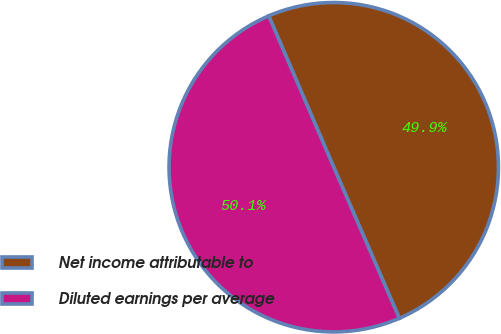Convert chart. <chart><loc_0><loc_0><loc_500><loc_500><pie_chart><fcel>Net income attributable to<fcel>Diluted earnings per average<nl><fcel>49.94%<fcel>50.06%<nl></chart> 